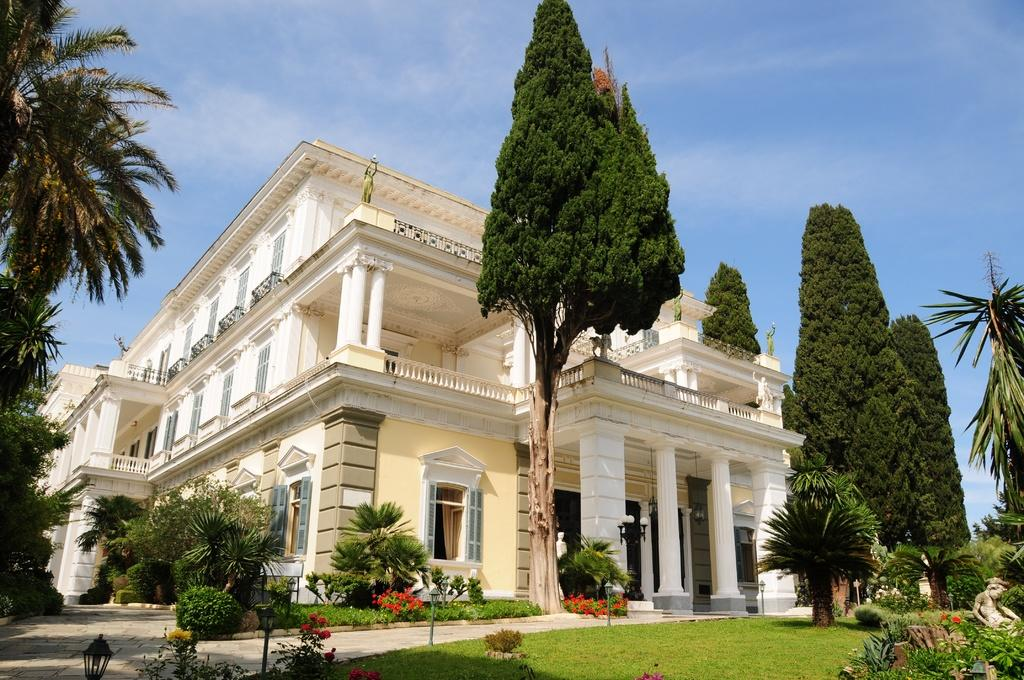What type of structure is visible in the image? There is a building in the image. What is located in front of the building? There are trees, plants, flowers, grass, metal rods, and lights visible in front of the building. Can you describe the vegetation in front of the building? There are trees, plants, and flowers in front of the building. What type of material are the metal rods made of? The metal rods in front of the building are made of metal. Are there any visible light sources in the image? Yes, there are lights visible in the image. How many letters are being rubbed by the uncle in the image? There are no letters or uncles present in the image. 